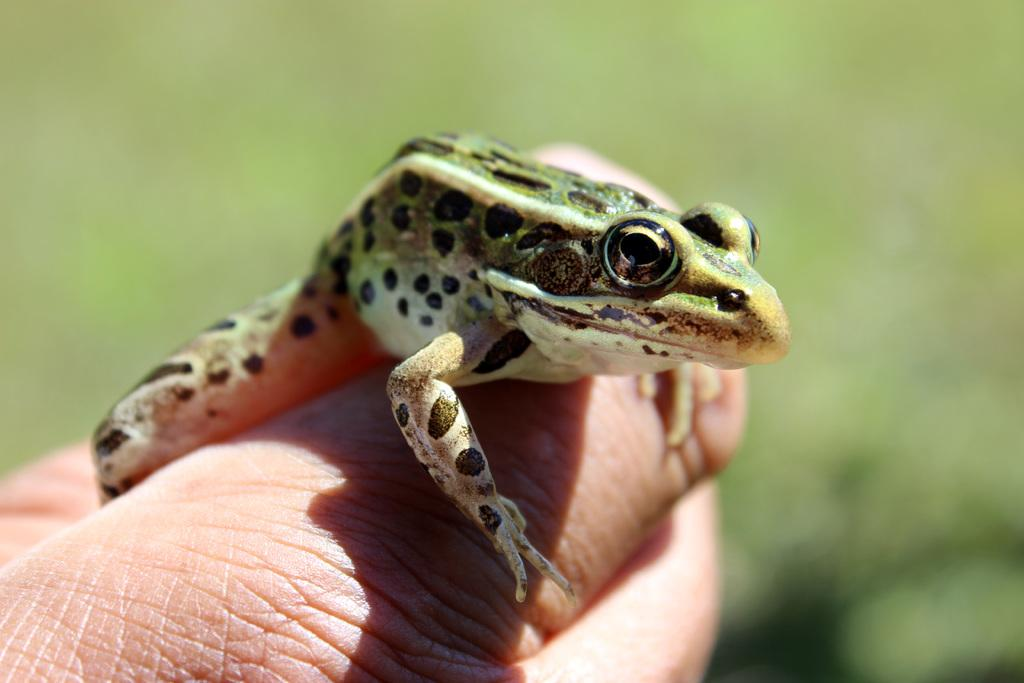What is the main subject in the foreground of the picture? There is a person's hand in the foreground of the picture. What is on the person's hand? There is a frog on the person's hand. Can you describe the background of the image? The background of the image is blurred. How does the frog draw the person's attention in the image? The frog does not draw the person's attention in the image, as it is already on the person's hand. Can you tell me the relationship between the person and the frog's father in the image? There is no information about the frog's father in the image, so we cannot determine the relationship between the person and the frog's father. 